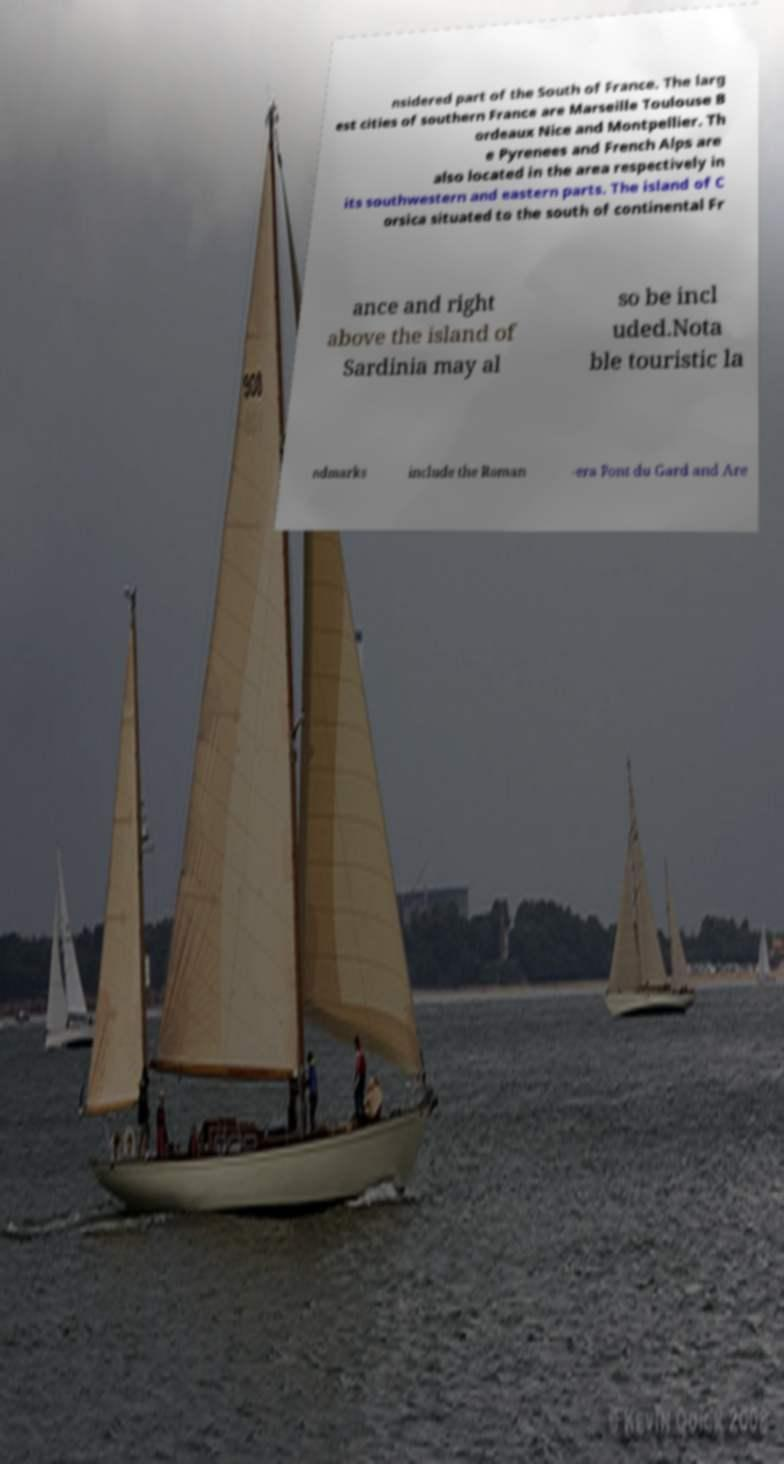Please identify and transcribe the text found in this image. nsidered part of the South of France. The larg est cities of southern France are Marseille Toulouse B ordeaux Nice and Montpellier. Th e Pyrenees and French Alps are also located in the area respectively in its southwestern and eastern parts. The island of C orsica situated to the south of continental Fr ance and right above the island of Sardinia may al so be incl uded.Nota ble touristic la ndmarks include the Roman -era Pont du Gard and Are 